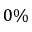<formula> <loc_0><loc_0><loc_500><loc_500>0 \%</formula> 